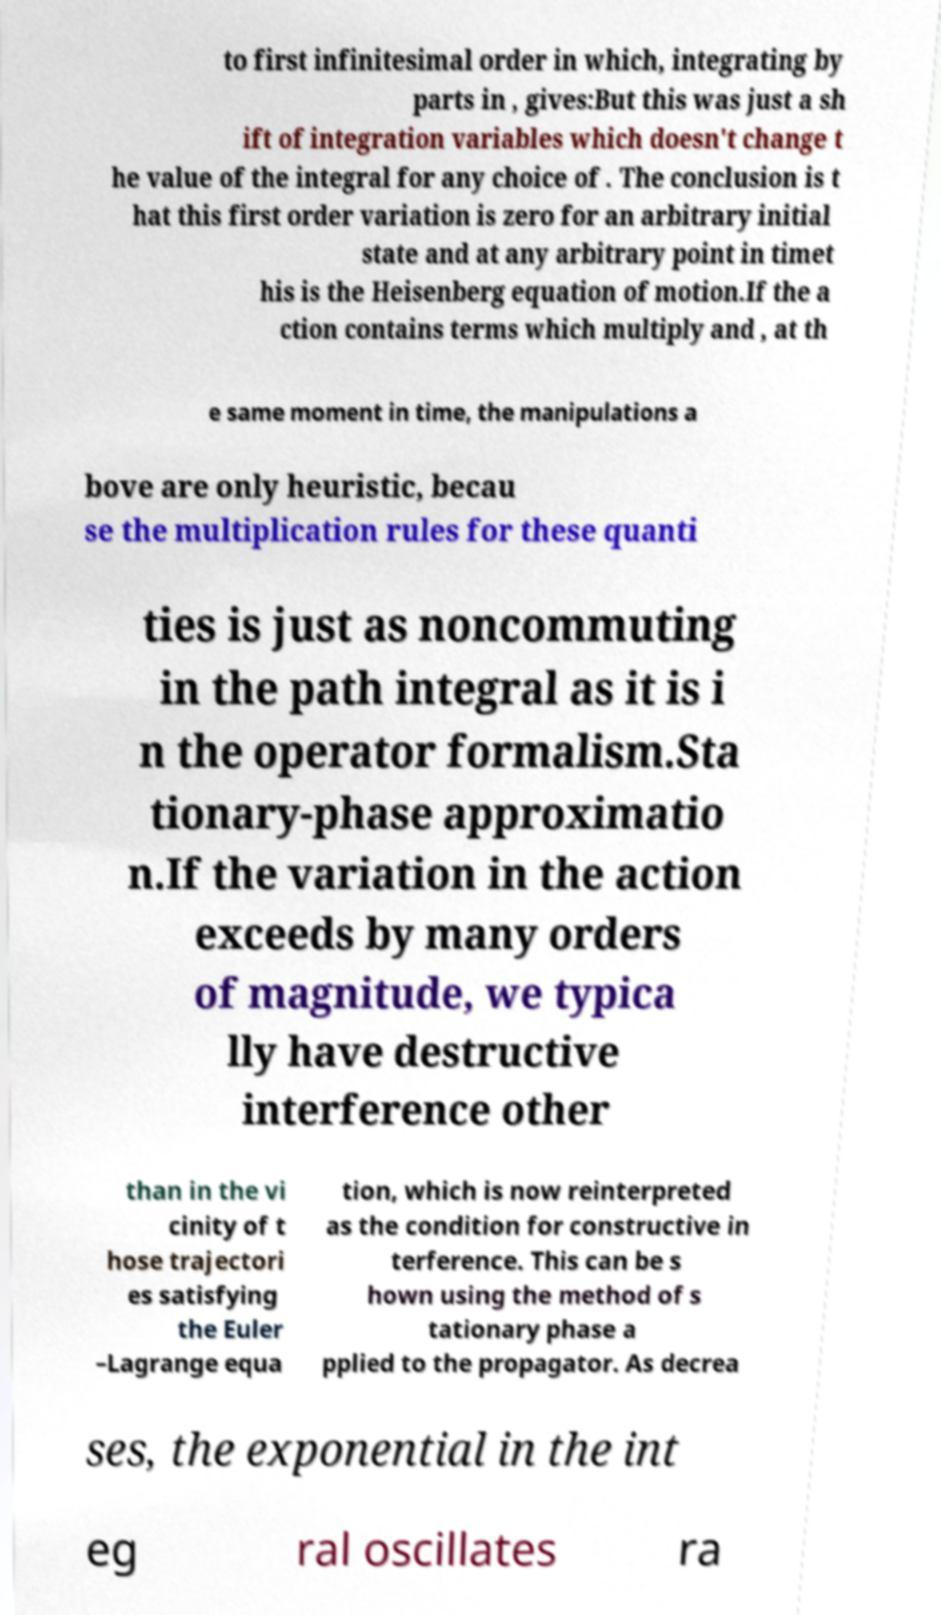Please read and relay the text visible in this image. What does it say? to first infinitesimal order in which, integrating by parts in , gives:But this was just a sh ift of integration variables which doesn't change t he value of the integral for any choice of . The conclusion is t hat this first order variation is zero for an arbitrary initial state and at any arbitrary point in timet his is the Heisenberg equation of motion.If the a ction contains terms which multiply and , at th e same moment in time, the manipulations a bove are only heuristic, becau se the multiplication rules for these quanti ties is just as noncommuting in the path integral as it is i n the operator formalism.Sta tionary-phase approximatio n.If the variation in the action exceeds by many orders of magnitude, we typica lly have destructive interference other than in the vi cinity of t hose trajectori es satisfying the Euler –Lagrange equa tion, which is now reinterpreted as the condition for constructive in terference. This can be s hown using the method of s tationary phase a pplied to the propagator. As decrea ses, the exponential in the int eg ral oscillates ra 